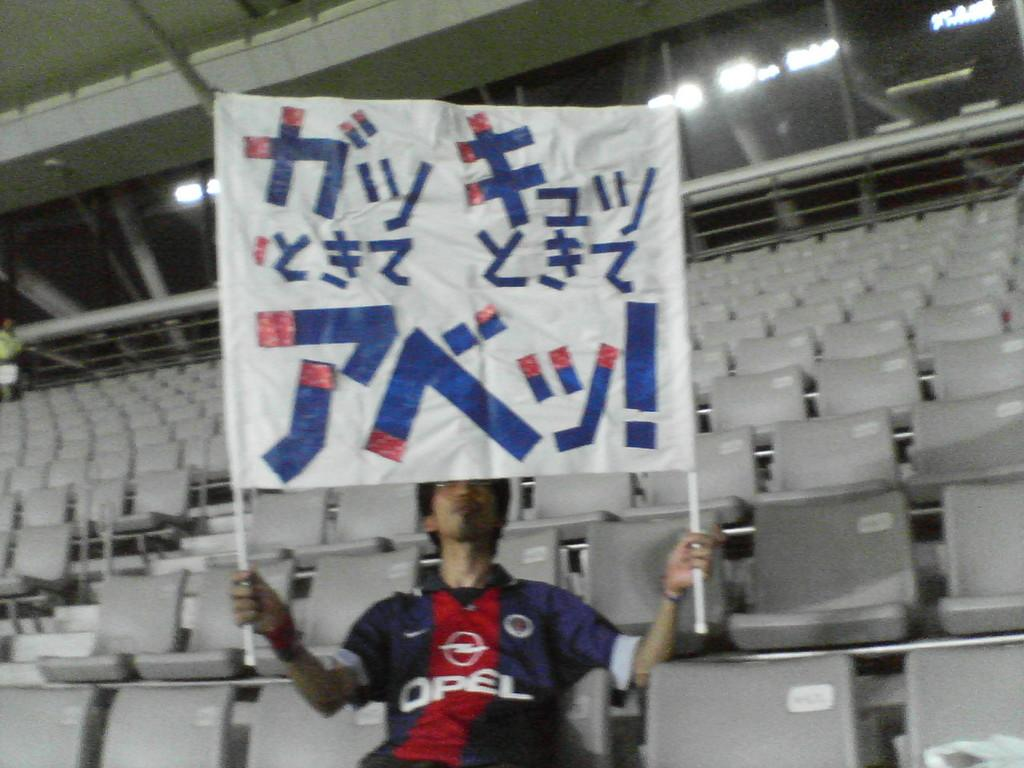<image>
Write a terse but informative summary of the picture. A man wearing a football top with OPEL printed on it holds up a banner with Japanese writing on it. 